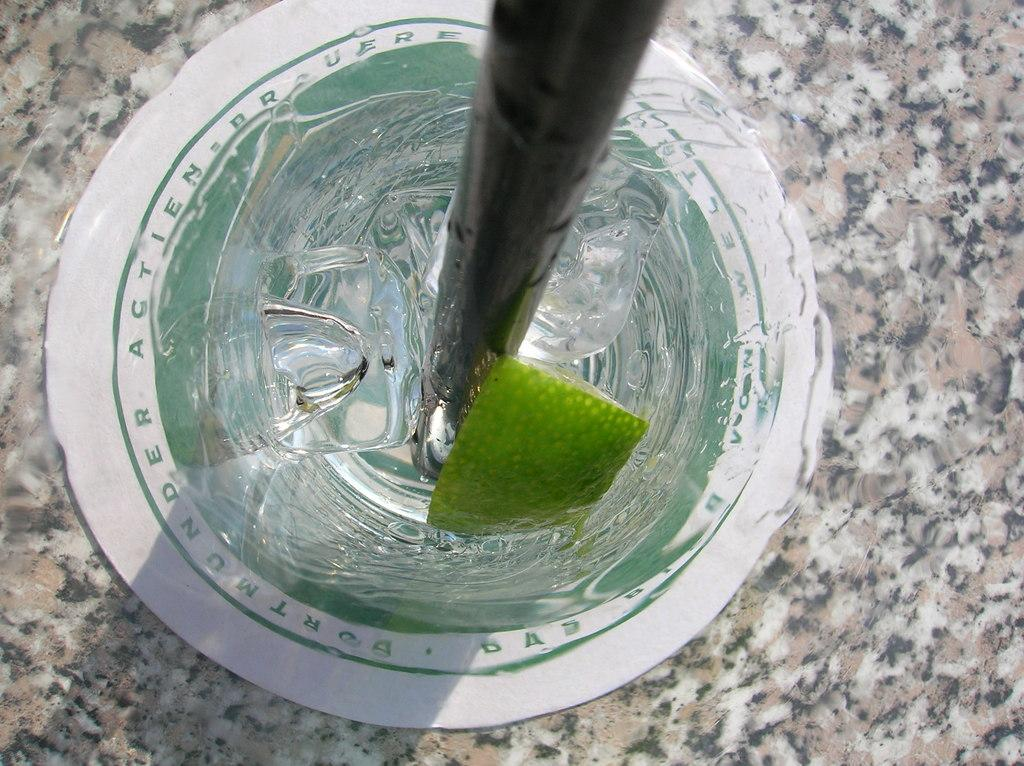What type of frozen water is present in the image? There are ice cubes in the image. What type of citrus fruit is present in the image? There is a piece of lemon in the image. What material is the wooden object made of in the image? The wooden object in the image is made of wood. What type of surface is visible in the image? There is a marble surface in the image. Can you see any cobwebs on the wooden object in the image? There is no mention of cobwebs in the image, so we cannot determine if any are present. What type of design is featured on the marble surface in the image? The marble surface in the image does not have any specific design mentioned in the provided facts. 